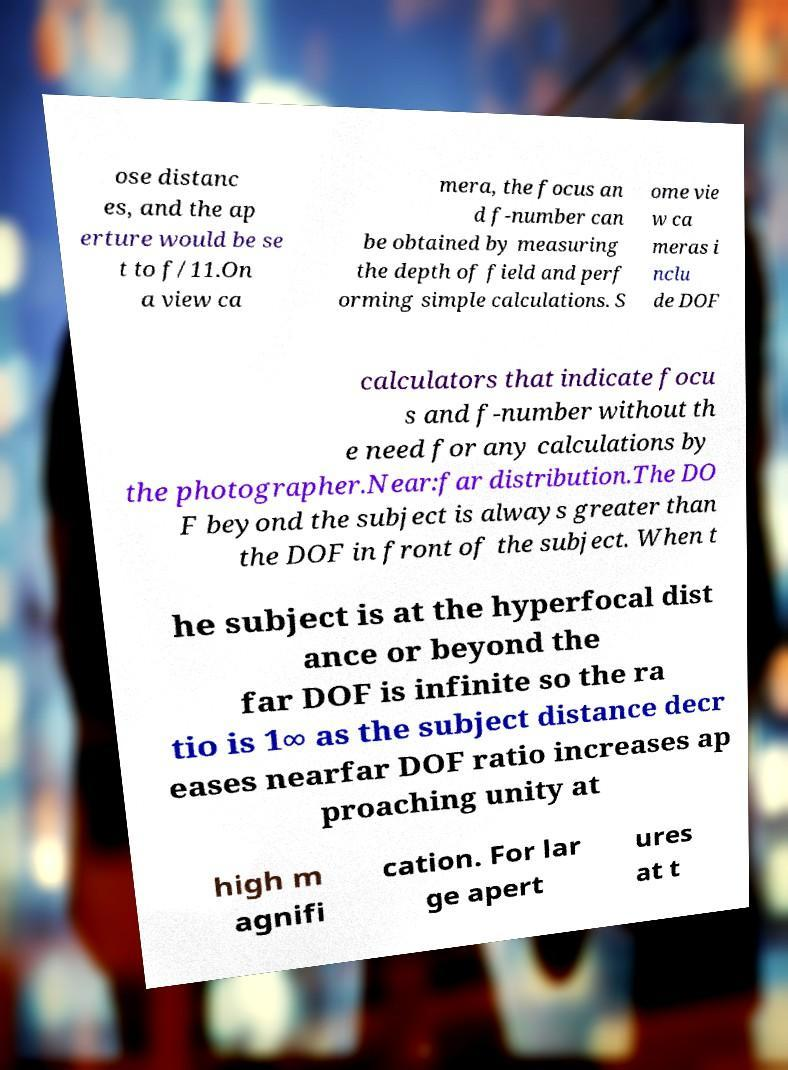Can you accurately transcribe the text from the provided image for me? ose distanc es, and the ap erture would be se t to f/11.On a view ca mera, the focus an d f-number can be obtained by measuring the depth of field and perf orming simple calculations. S ome vie w ca meras i nclu de DOF calculators that indicate focu s and f-number without th e need for any calculations by the photographer.Near:far distribution.The DO F beyond the subject is always greater than the DOF in front of the subject. When t he subject is at the hyperfocal dist ance or beyond the far DOF is infinite so the ra tio is 1∞ as the subject distance decr eases nearfar DOF ratio increases ap proaching unity at high m agnifi cation. For lar ge apert ures at t 